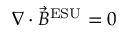<formula> <loc_0><loc_0><loc_500><loc_500>\nabla \cdot { \vec { B } } ^ { E S U } = 0</formula> 